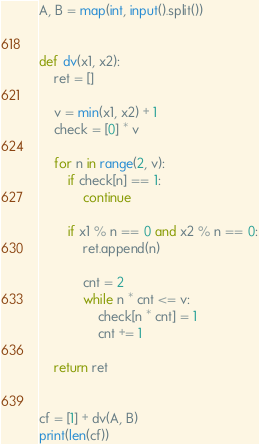Convert code to text. <code><loc_0><loc_0><loc_500><loc_500><_Python_>A, B = map(int, input().split())


def dv(x1, x2):
    ret = []

    v = min(x1, x2) + 1
    check = [0] * v

    for n in range(2, v):
        if check[n] == 1:
            continue

        if x1 % n == 0 and x2 % n == 0:
            ret.append(n)

            cnt = 2
            while n * cnt <= v:
                check[n * cnt] = 1
                cnt += 1

    return ret


cf = [1] + dv(A, B)
print(len(cf))</code> 